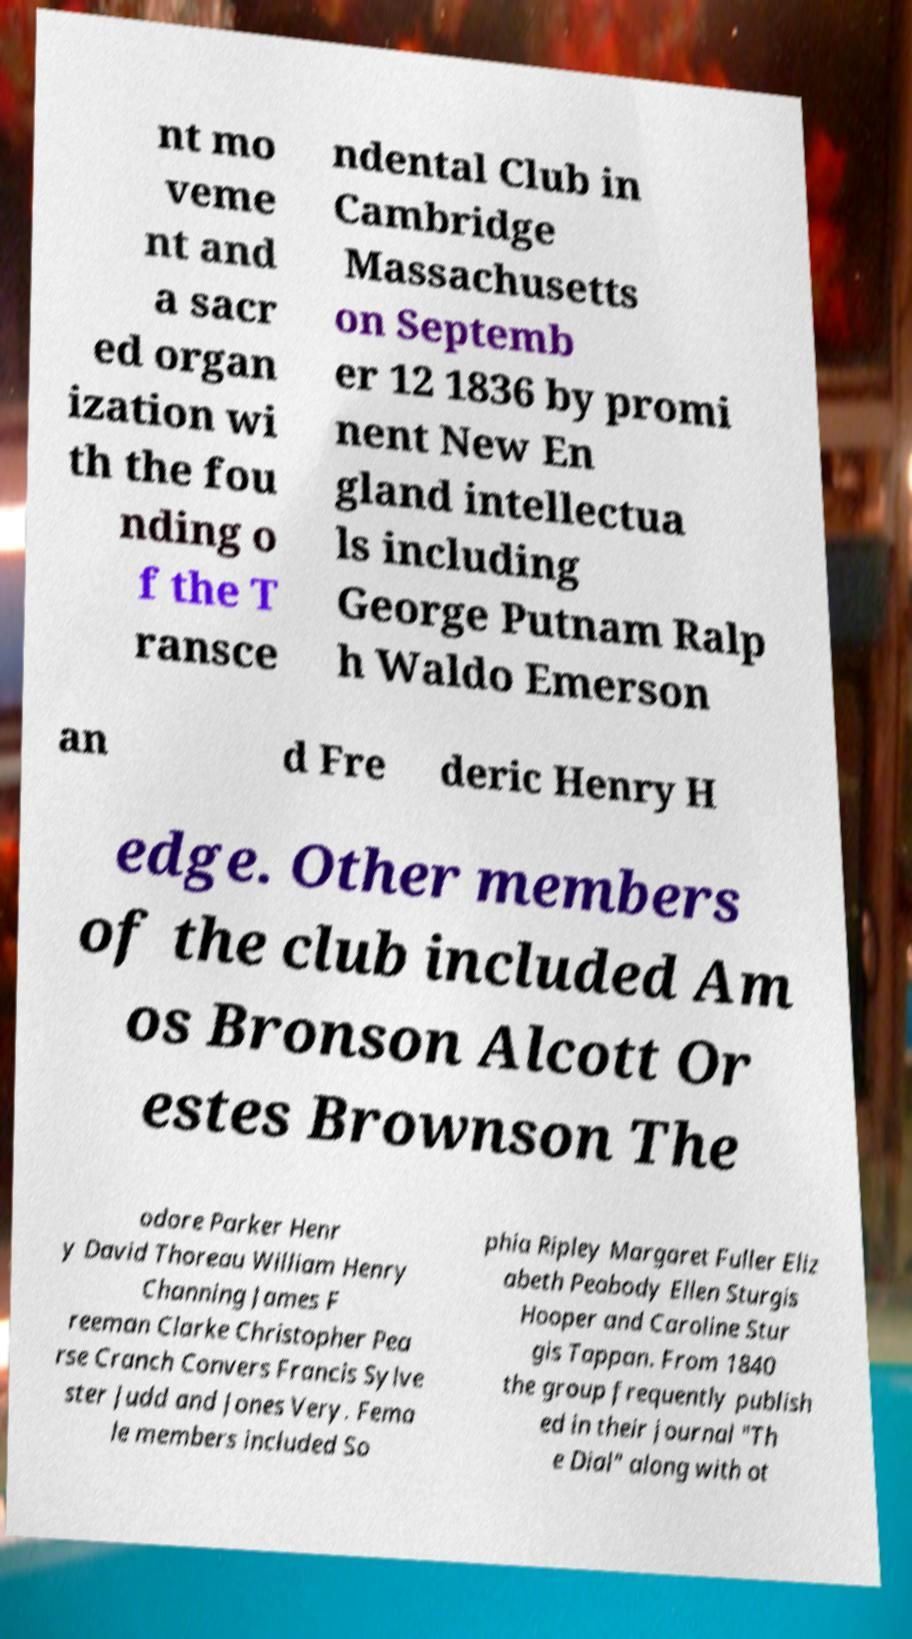For documentation purposes, I need the text within this image transcribed. Could you provide that? nt mo veme nt and a sacr ed organ ization wi th the fou nding o f the T ransce ndental Club in Cambridge Massachusetts on Septemb er 12 1836 by promi nent New En gland intellectua ls including George Putnam Ralp h Waldo Emerson an d Fre deric Henry H edge. Other members of the club included Am os Bronson Alcott Or estes Brownson The odore Parker Henr y David Thoreau William Henry Channing James F reeman Clarke Christopher Pea rse Cranch Convers Francis Sylve ster Judd and Jones Very. Fema le members included So phia Ripley Margaret Fuller Eliz abeth Peabody Ellen Sturgis Hooper and Caroline Stur gis Tappan. From 1840 the group frequently publish ed in their journal "Th e Dial" along with ot 